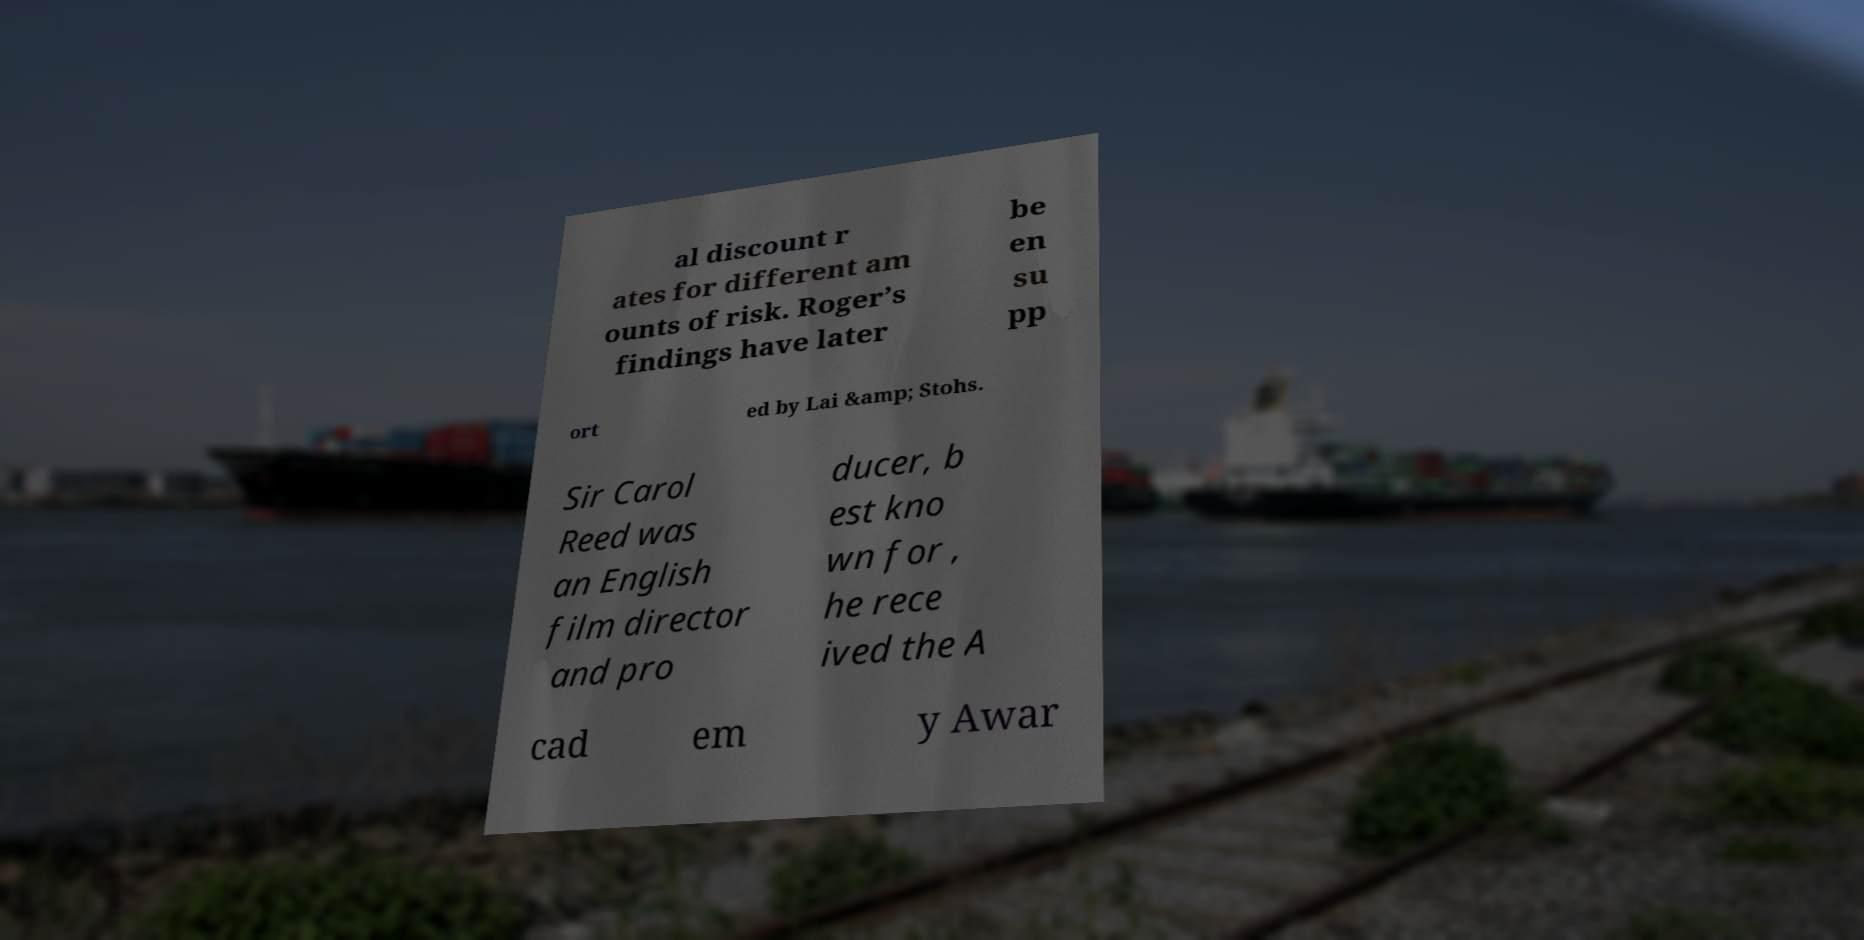Can you read and provide the text displayed in the image?This photo seems to have some interesting text. Can you extract and type it out for me? al discount r ates for different am ounts of risk. Roger’s findings have later be en su pp ort ed by Lai &amp; Stohs. Sir Carol Reed was an English film director and pro ducer, b est kno wn for , he rece ived the A cad em y Awar 